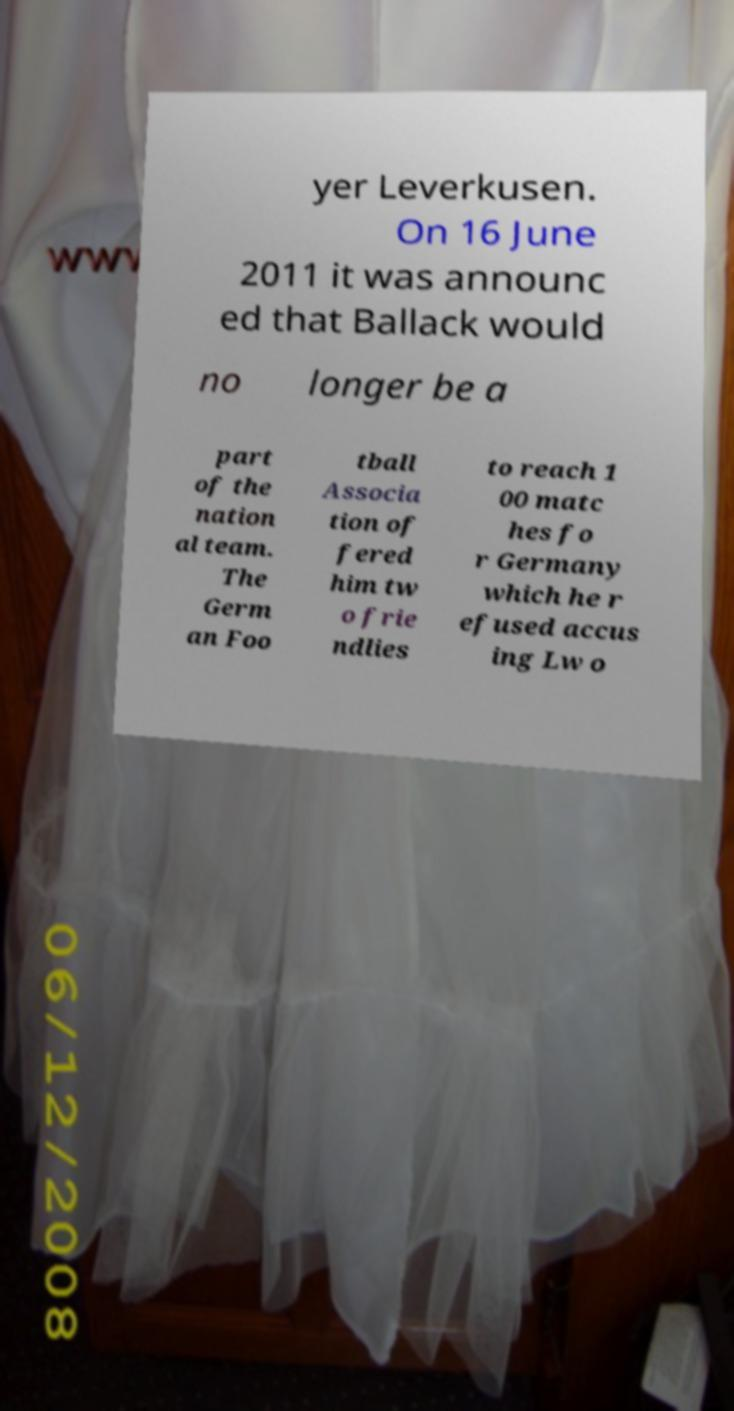There's text embedded in this image that I need extracted. Can you transcribe it verbatim? yer Leverkusen. On 16 June 2011 it was announc ed that Ballack would no longer be a part of the nation al team. The Germ an Foo tball Associa tion of fered him tw o frie ndlies to reach 1 00 matc hes fo r Germany which he r efused accus ing Lw o 